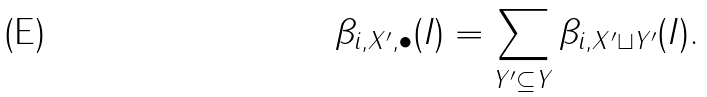Convert formula to latex. <formula><loc_0><loc_0><loc_500><loc_500>\beta _ { i , X ^ { \prime } , \bullet } ( I ) = \sum _ { Y ^ { \prime } \subseteq Y } \beta _ { i , X ^ { \prime } \sqcup Y ^ { \prime } } ( I ) .</formula> 